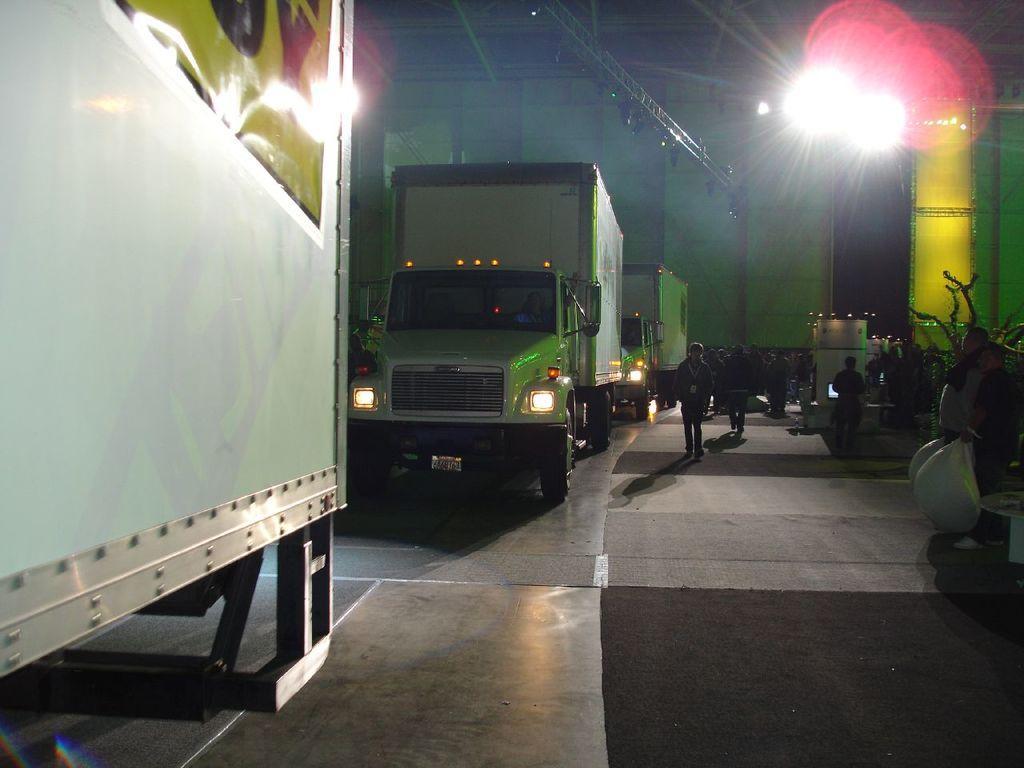Can you describe this image briefly? In this image we can see few vehicles, people, a person is holding some objects and there are lights, metal rod, and few other objects on the floor. 